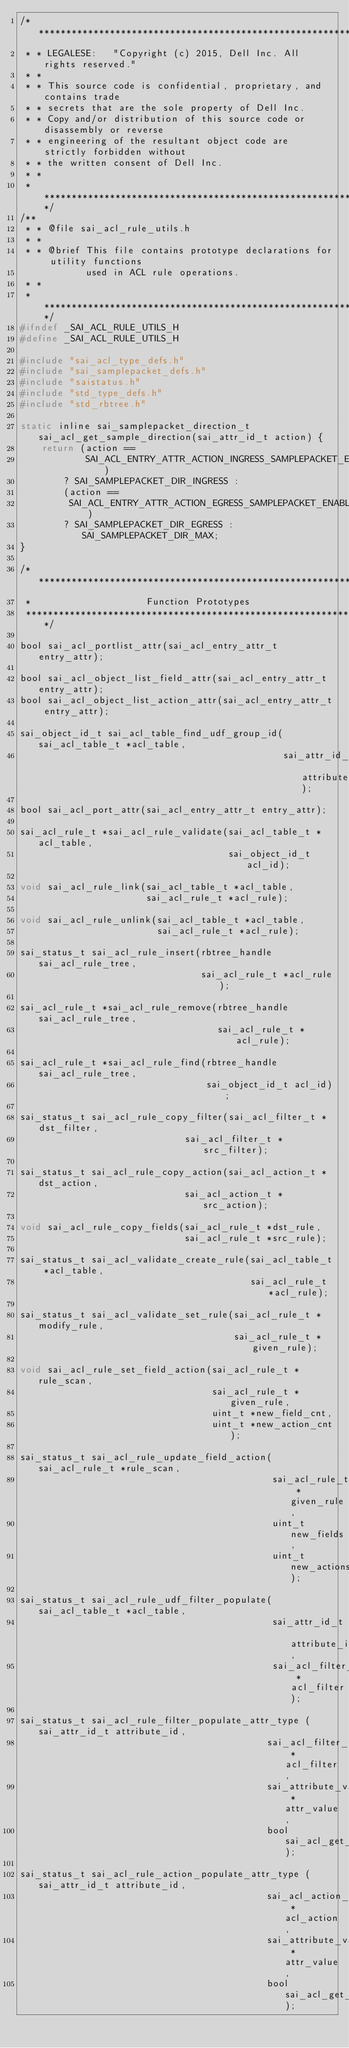Convert code to text. <code><loc_0><loc_0><loc_500><loc_500><_C_>/************************************************************************
 * * LEGALESE:   "Copyright (c) 2015, Dell Inc. All rights reserved."
 * *
 * * This source code is confidential, proprietary, and contains trade
 * * secrets that are the sole property of Dell Inc.
 * * Copy and/or distribution of this source code or disassembly or reverse
 * * engineering of the resultant object code are strictly forbidden without
 * * the written consent of Dell Inc.
 * *
 * ************************************************************************/
/**
 * * @file sai_acl_rule_utils.h
 * *
 * * @brief This file contains prototype declarations for utility functions
            used in ACL rule operations.
 * *
 * *************************************************************************/
#ifndef _SAI_ACL_RULE_UTILS_H
#define _SAI_ACL_RULE_UTILS_H

#include "sai_acl_type_defs.h"
#include "sai_samplepacket_defs.h"
#include "saistatus.h"
#include "std_type_defs.h"
#include "std_rbtree.h"

static inline sai_samplepacket_direction_t sai_acl_get_sample_direction(sai_attr_id_t action) {
    return (action ==
            SAI_ACL_ENTRY_ATTR_ACTION_INGRESS_SAMPLEPACKET_ENABLE)
        ? SAI_SAMPLEPACKET_DIR_INGRESS :
        (action ==
         SAI_ACL_ENTRY_ATTR_ACTION_EGRESS_SAMPLEPACKET_ENABLE)
        ? SAI_SAMPLEPACKET_DIR_EGRESS : SAI_SAMPLEPACKET_DIR_MAX;
}

/**************************************************************************
 *                     Function Prototypes
 **************************************************************************/

bool sai_acl_portlist_attr(sai_acl_entry_attr_t entry_attr);

bool sai_acl_object_list_field_attr(sai_acl_entry_attr_t entry_attr);
bool sai_acl_object_list_action_attr(sai_acl_entry_attr_t entry_attr);

sai_object_id_t sai_acl_table_find_udf_group_id(sai_acl_table_t *acl_table,
                                                sai_attr_id_t attribute_id);

bool sai_acl_port_attr(sai_acl_entry_attr_t entry_attr);

sai_acl_rule_t *sai_acl_rule_validate(sai_acl_table_t *acl_table,
                                      sai_object_id_t acl_id);

void sai_acl_rule_link(sai_acl_table_t *acl_table,
                       sai_acl_rule_t *acl_rule);

void sai_acl_rule_unlink(sai_acl_table_t *acl_table,
                         sai_acl_rule_t *acl_rule);

sai_status_t sai_acl_rule_insert(rbtree_handle sai_acl_rule_tree,
                                 sai_acl_rule_t *acl_rule);

sai_acl_rule_t *sai_acl_rule_remove(rbtree_handle sai_acl_rule_tree,
                                    sai_acl_rule_t *acl_rule);

sai_acl_rule_t *sai_acl_rule_find(rbtree_handle sai_acl_rule_tree,
                                  sai_object_id_t acl_id);

sai_status_t sai_acl_rule_copy_filter(sai_acl_filter_t *dst_filter,
                              sai_acl_filter_t *src_filter);

sai_status_t sai_acl_rule_copy_action(sai_acl_action_t *dst_action,
                              sai_acl_action_t *src_action);

void sai_acl_rule_copy_fields(sai_acl_rule_t *dst_rule,
                              sai_acl_rule_t *src_rule);

sai_status_t sai_acl_validate_create_rule(sai_acl_table_t *acl_table,
                                          sai_acl_rule_t *acl_rule);

sai_status_t sai_acl_validate_set_rule(sai_acl_rule_t *modify_rule,
                                       sai_acl_rule_t *given_rule);

void sai_acl_rule_set_field_action(sai_acl_rule_t *rule_scan,
                                   sai_acl_rule_t *given_rule,
                                   uint_t *new_field_cnt,
                                   uint_t *new_action_cnt);

sai_status_t sai_acl_rule_update_field_action(sai_acl_rule_t *rule_scan,
                                              sai_acl_rule_t *given_rule,
                                              uint_t new_fields,
                                              uint_t new_actions);

sai_status_t sai_acl_rule_udf_filter_populate(sai_acl_table_t *acl_table,
                                              sai_attr_id_t attribute_id,
                                              sai_acl_filter_t *acl_filter);

sai_status_t sai_acl_rule_filter_populate_attr_type (sai_attr_id_t attribute_id,
                                             sai_acl_filter_t *acl_filter,
                                             sai_attribute_value_t *attr_value,
                                             bool sai_acl_get_api);

sai_status_t sai_acl_rule_action_populate_attr_type (sai_attr_id_t attribute_id,
                                             sai_acl_action_t *acl_action,
                                             sai_attribute_value_t *attr_value,
                                             bool sai_acl_get_api);
</code> 